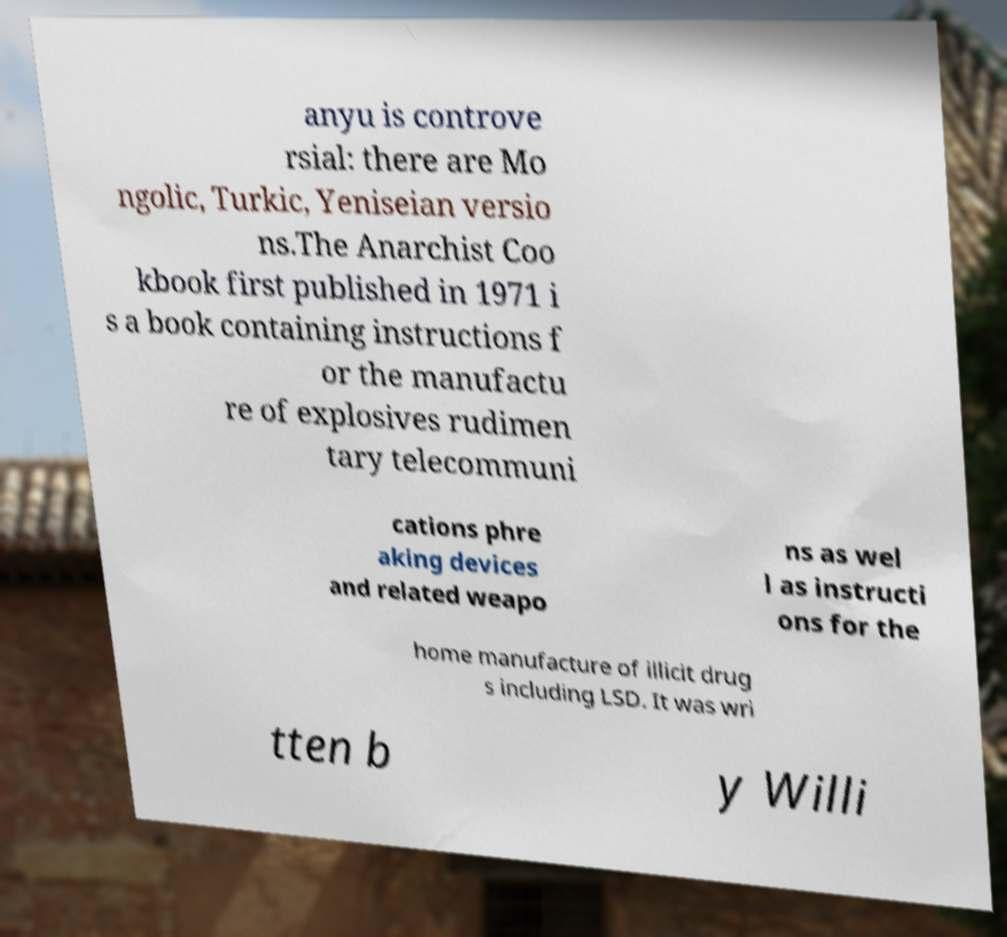Please read and relay the text visible in this image. What does it say? anyu is controve rsial: there are Mo ngolic, Turkic, Yeniseian versio ns.The Anarchist Coo kbook first published in 1971 i s a book containing instructions f or the manufactu re of explosives rudimen tary telecommuni cations phre aking devices and related weapo ns as wel l as instructi ons for the home manufacture of illicit drug s including LSD. It was wri tten b y Willi 